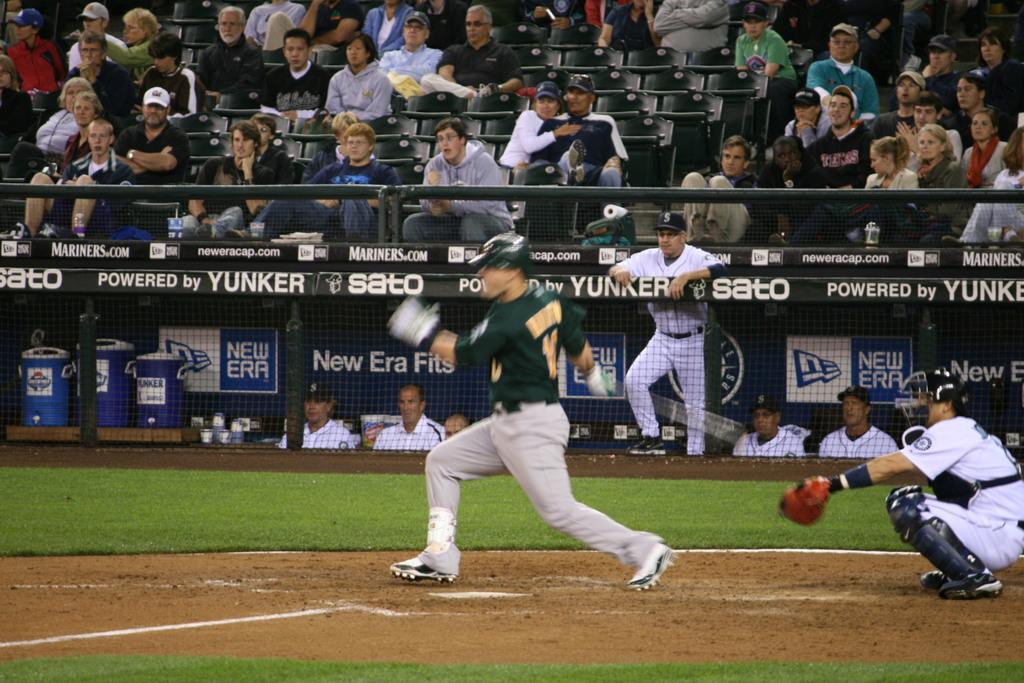Who is the sponsor of this team?
Offer a terse response. Yunker. 